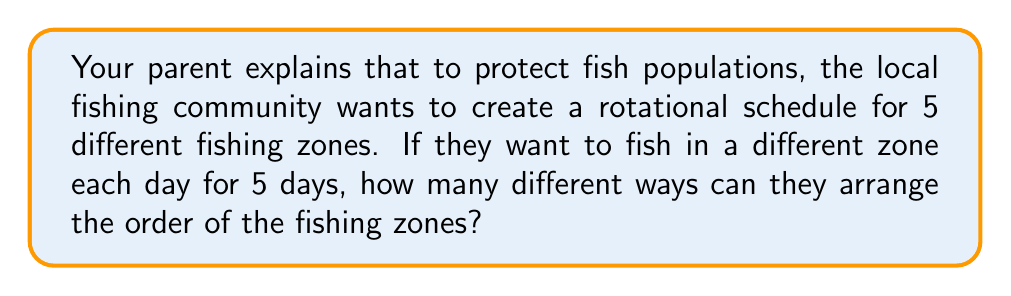Show me your answer to this math problem. Let's approach this step-by-step:

1) We have 5 fishing zones, and we need to arrange all 5 of them in a specific order.

2) This is a perfect scenario for using permutations. We're arranging all the available options (5 zones) without repetition.

3) The formula for permutations of n distinct objects is:

   $$P(n) = n!$$

   Where $n!$ means the factorial of n.

4) In this case, $n = 5$ (because we have 5 fishing zones).

5) So, we need to calculate:

   $$P(5) = 5!$$

6) Let's expand this:
   
   $$5! = 5 \times 4 \times 3 \times 2 \times 1 = 120$$

Therefore, there are 120 different ways to arrange the 5 fishing zones over 5 days.
Answer: 120 